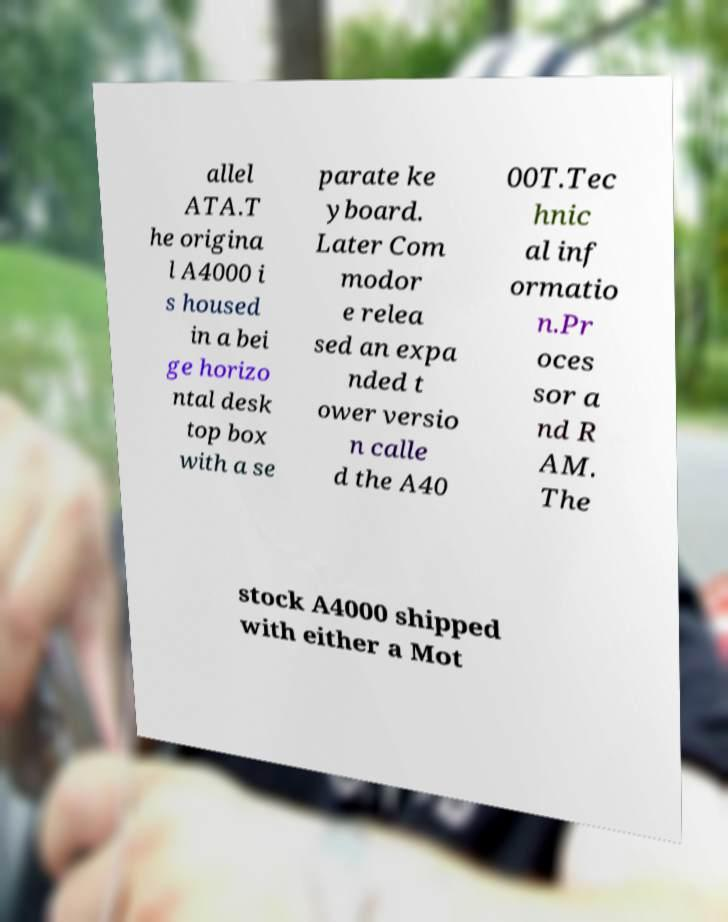What messages or text are displayed in this image? I need them in a readable, typed format. allel ATA.T he origina l A4000 i s housed in a bei ge horizo ntal desk top box with a se parate ke yboard. Later Com modor e relea sed an expa nded t ower versio n calle d the A40 00T.Tec hnic al inf ormatio n.Pr oces sor a nd R AM. The stock A4000 shipped with either a Mot 